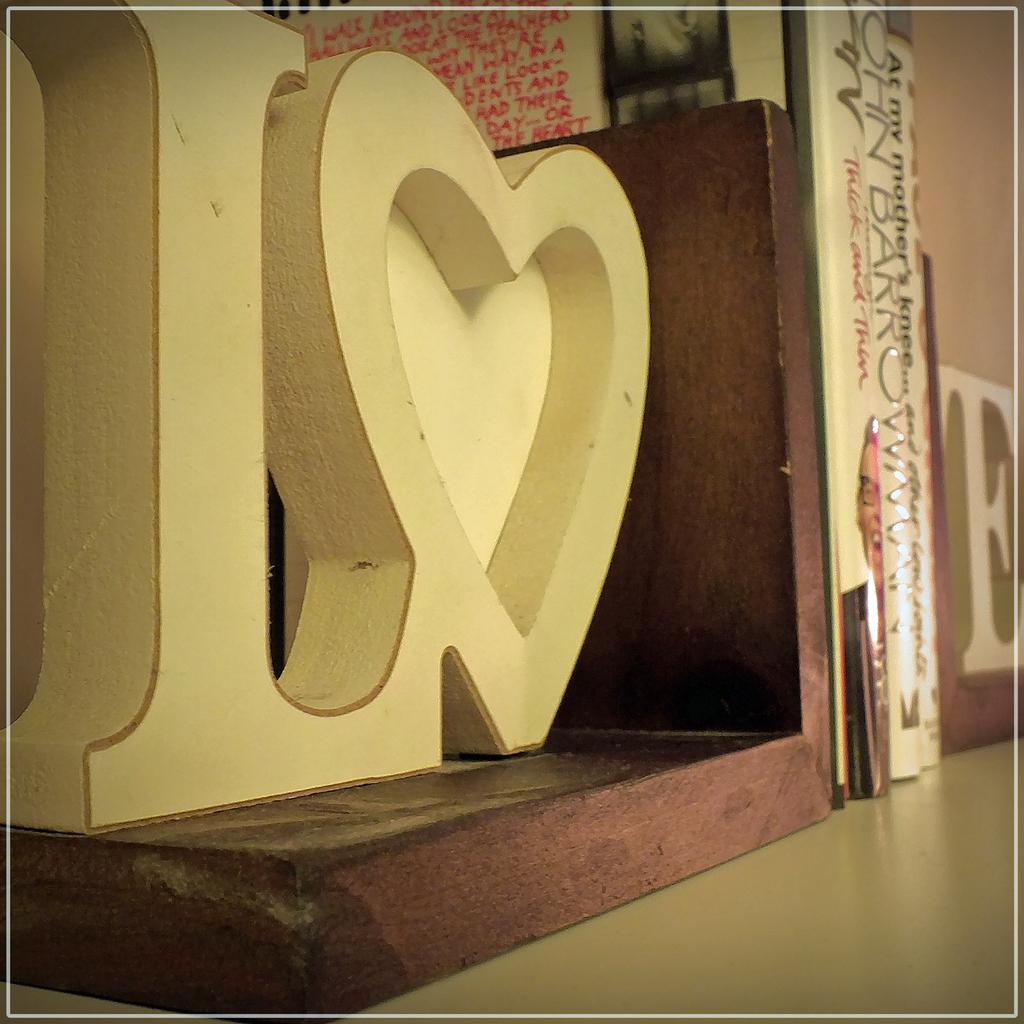<image>
Provide a brief description of the given image. Some books including a copy of At My Mother's Knee stand on a shelf between two bookends. 